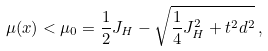<formula> <loc_0><loc_0><loc_500><loc_500>\mu ( x ) < \mu _ { 0 } = \frac { 1 } { 2 } J _ { H } - \sqrt { \frac { 1 } { 4 } J _ { H } ^ { 2 } + t ^ { 2 } d ^ { 2 } } \, ,</formula> 